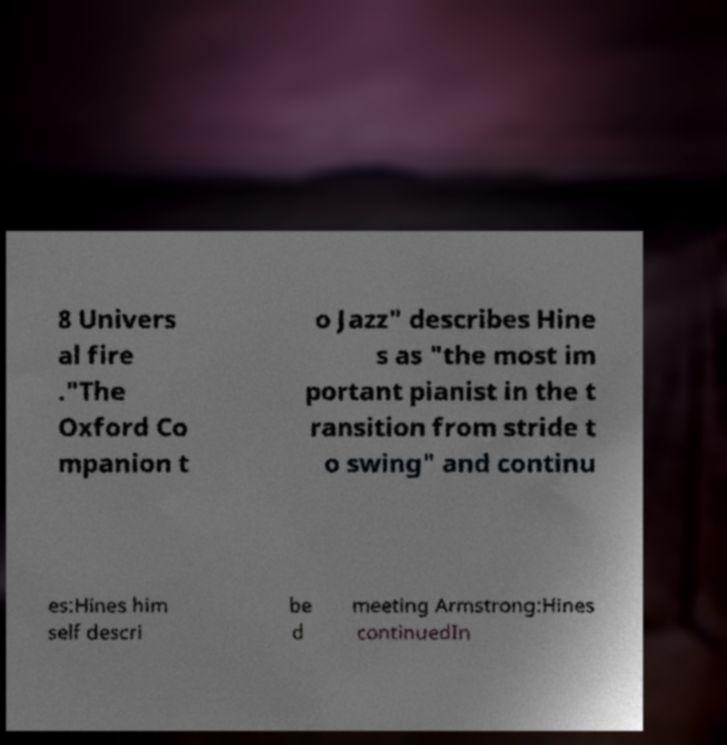Could you assist in decoding the text presented in this image and type it out clearly? 8 Univers al fire ."The Oxford Co mpanion t o Jazz" describes Hine s as "the most im portant pianist in the t ransition from stride t o swing" and continu es:Hines him self descri be d meeting Armstrong:Hines continuedIn 